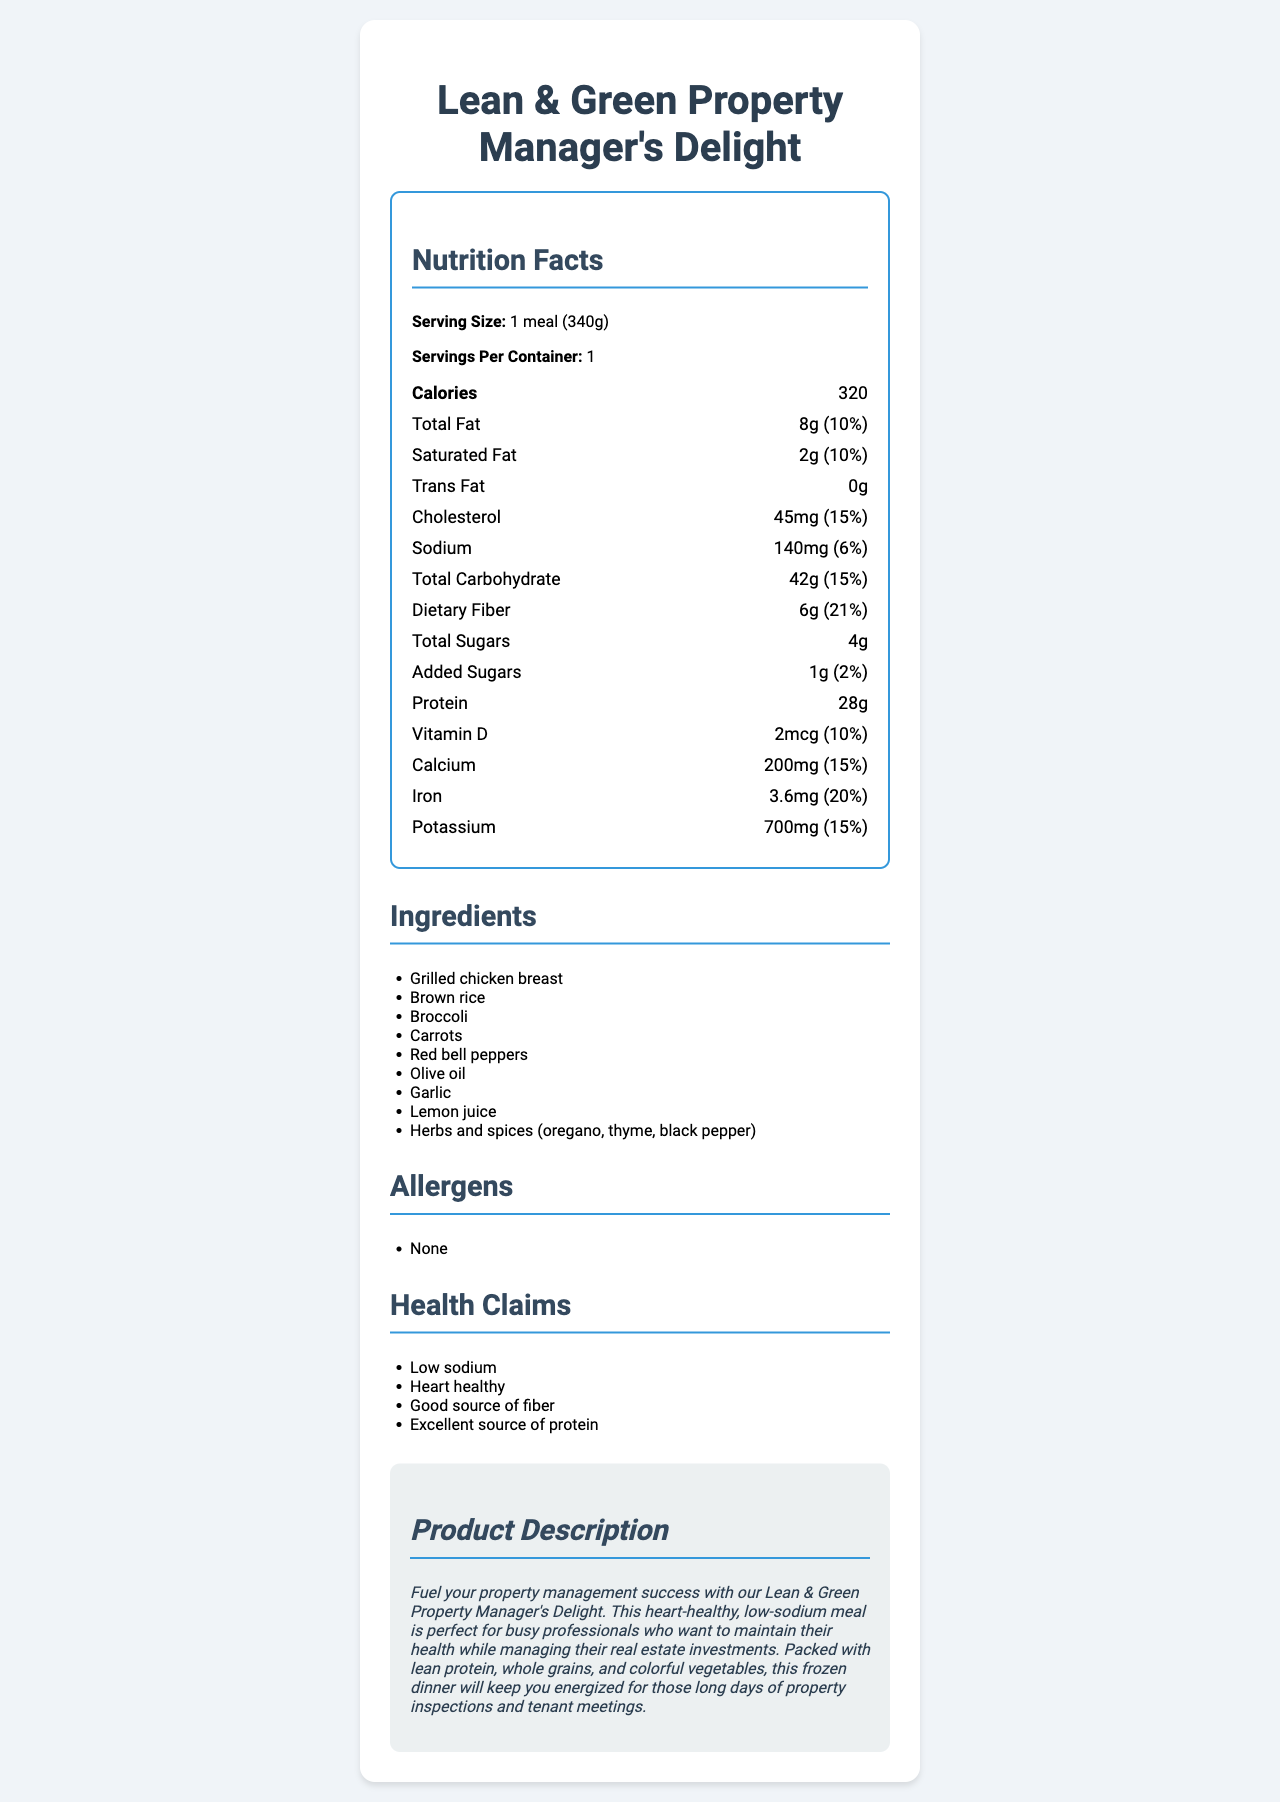what is the serving size? The serving size is listed as "1 meal (340g)" in the document, located at the beginning near the nutrition facts heading.
Answer: 1 meal (340g) how much sodium is in one serving? The amount of sodium is listed as "140mg" under the nutrition facts section.
Answer: 140mg what percentage of the daily value for fiber does this meal provide? The daily value percentage for dietary fiber is stated as "21%" in the nutrient breakdown.
Answer: 21% what are the two main sources of protein in this meal? The ingredients list includes "Grilled chicken breast" and "Brown rice" as the two main sources of protein.
Answer: Grilled chicken breast, brown rice how many grams of saturated fat does this frozen dinner contain? The amount of saturated fat is listed under the nutrition facts as "2g".
Answer: 2g this meal is marketed as being low in which of the following: A. Calories B. Sodium C. Fat D. Carbohydrates The health claims section states "Low sodium" which indicates that this meal is marketed as being low in sodium.
Answer: B which ingredient is not a vegetable in this meal? A. Broccoli B. Carrots C. Olive oil D. Red bell peppers Olive oil is not a vegetable; it is a fat derived from olive fruit.
Answer: C is this meal suitable for someone with a gluten allergy? The allergen section lists "None," but it doesn't specify whether gluten is present, which isn't sufficient for a definitive answer.
Answer: Not enough information how does the document describe the marketing of this meal? The marketing description section elaborates that the meal is targeted at busy property managers who need a health-conscious meal option.
Answer: Fuel your property management success with our Lean & Green Property Manager's Delight. This heart-healthy, low-sodium meal... summarize the main components and benefits of this frozen dinner. The meal focuses on being heart-healthy and low in sodium while providing significant protein and fiber. The main target audience is property managers who require a nutritious and convenient meal option.
Answer: The Lean & Green Property Manager's Delight is a low-sodium, heart-healthy frozen meal that contains 320 calories, 8g of total fat, and 28g of protein per serving. It includes various whole ingredients such as grilled chicken breast, brown rice, and vegetables. This meal provides substantial dietary fiber and is free of common allergens. Specifically marketed towards health-conscious property managers, it aims to keep professionals energized throughout their workday. why is this meal considered heart-healthy? Being low in sodium (140mg) and including heart-healthy ingredients like lean chicken breast and olive oil, along with providing substantial dietary fiber, makes this meal beneficial for heart health.
Answer: Because it is low in sodium and provides a balanced amount of healthy fats, dietary fiber, and lean protein. what is the daily value percentage of vitamin D provided per serving? The daily value percentage for vitamin D is listed as "10%" in the nutrition facts section.
Answer: 10% how much total carbohydrate is in one serving? The total carbohydrate amount in one serving is listed as "42g" in the document.
Answer: 42g is there any trans fat in this meal? The document states "0g" under the trans fat section, indicating there is no trans fat in this meal.
Answer: No which ingredient provides a citrus flavor to the meal? The ingredients list includes "Lemon juice," which is known for providing a citrus flavor to dishes.
Answer: Lemon juice 